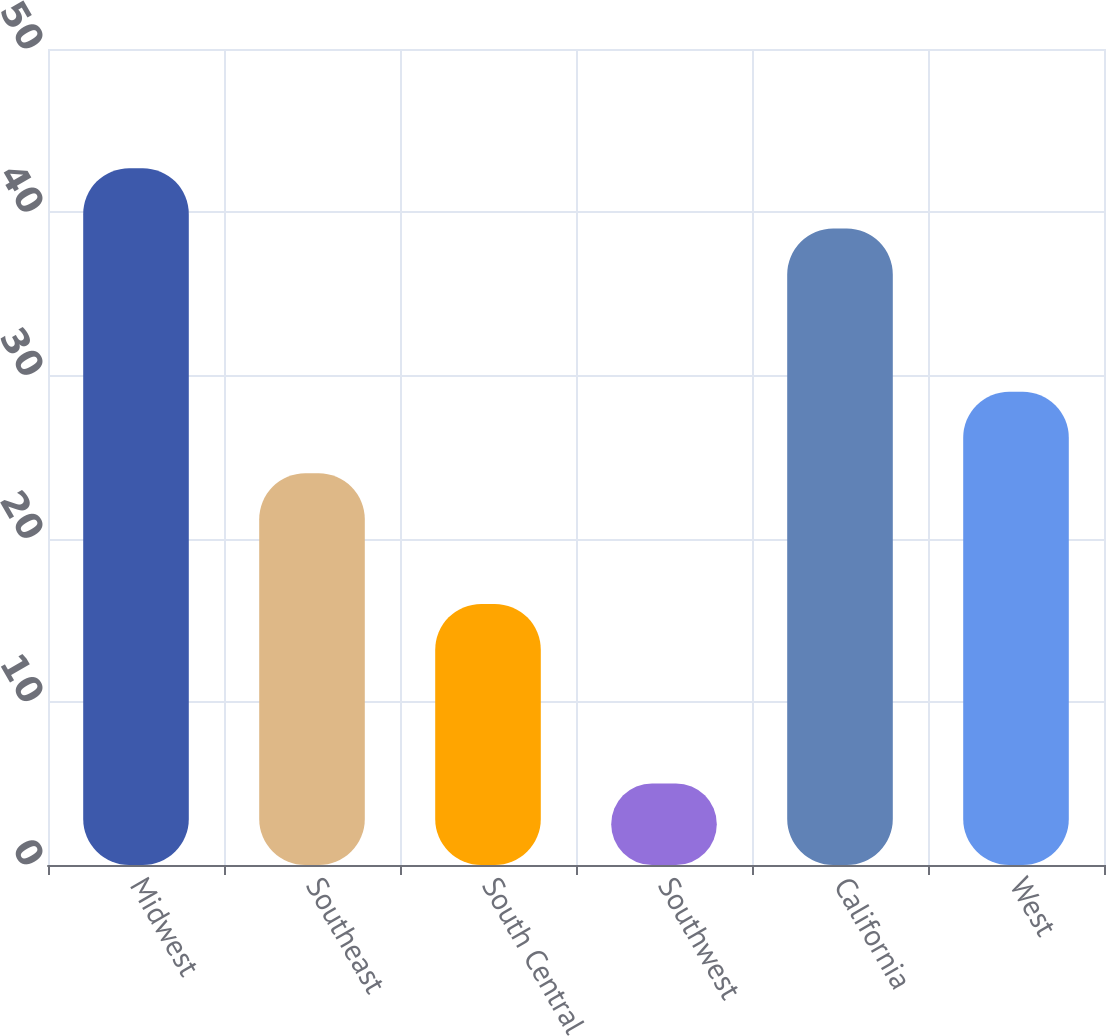Convert chart. <chart><loc_0><loc_0><loc_500><loc_500><bar_chart><fcel>Midwest<fcel>Southeast<fcel>South Central<fcel>Southwest<fcel>California<fcel>West<nl><fcel>42.7<fcel>24<fcel>16<fcel>5<fcel>39<fcel>29<nl></chart> 